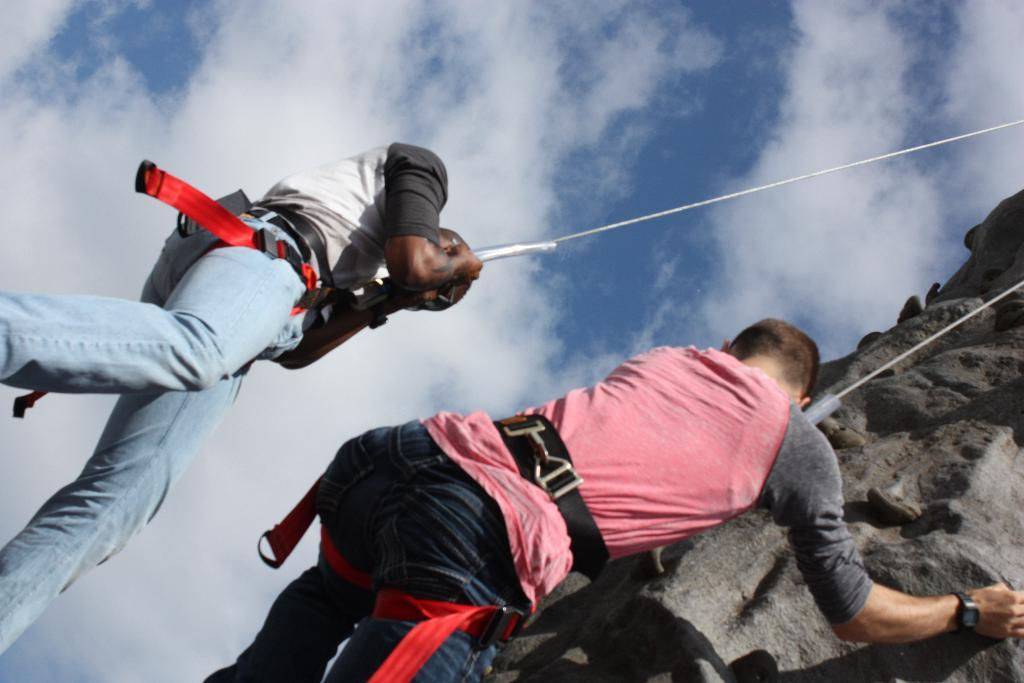How many people are in the image? There are two men in the image. What are the men doing in the image? The men are climbing a cliff. What are the men using to assist them in climbing the cliff? The men are using ropes for assistance. What can be seen in the sky in the image? The sky is visible in the image, and it is partly cloudy. What is the weather like in the image? The sun is shining in the image, indicating that it is likely a sunny day. What type of board can be seen in the image? There is no board present in the image. 